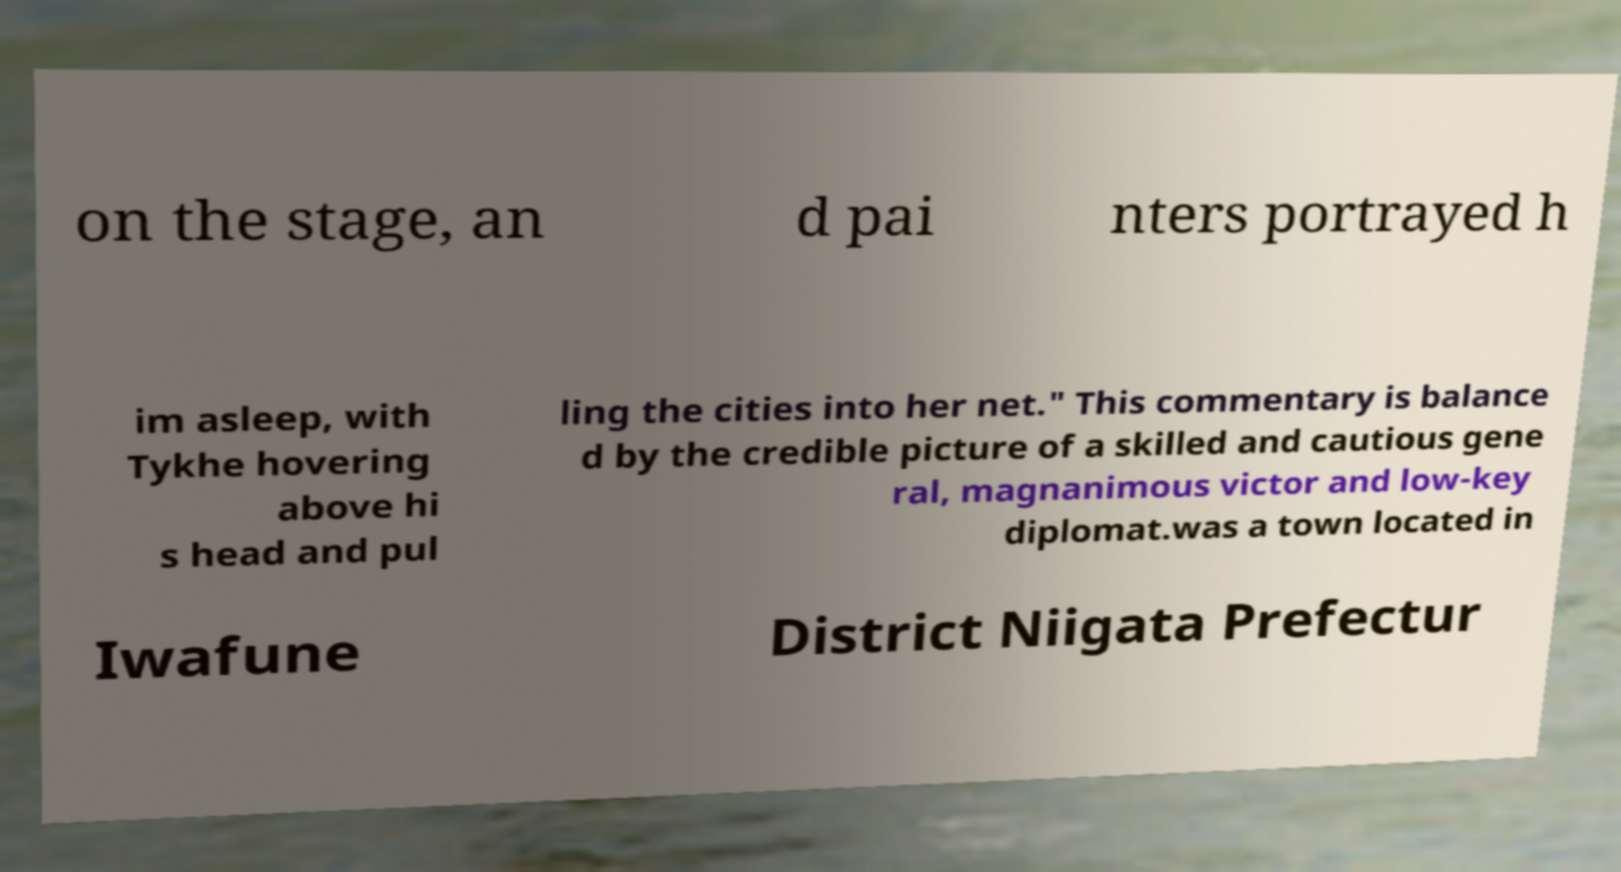Please read and relay the text visible in this image. What does it say? on the stage, an d pai nters portrayed h im asleep, with Tykhe hovering above hi s head and pul ling the cities into her net." This commentary is balance d by the credible picture of a skilled and cautious gene ral, magnanimous victor and low-key diplomat.was a town located in Iwafune District Niigata Prefectur 